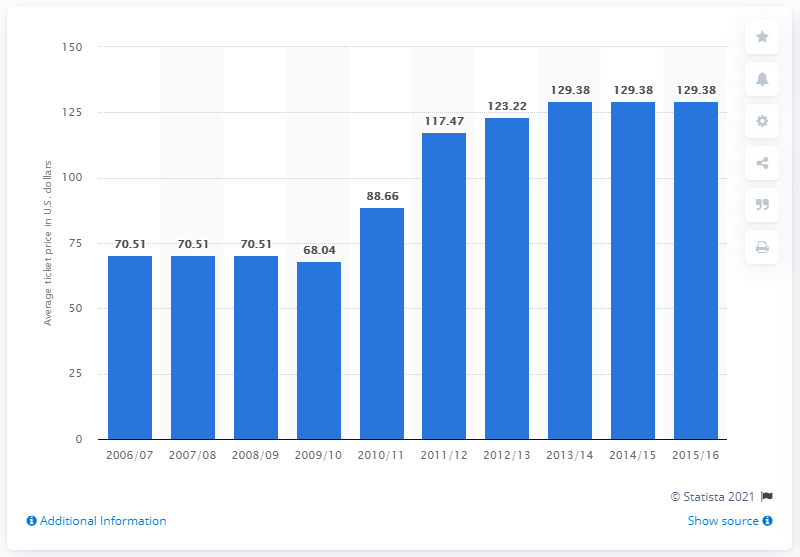Identify some key points in this picture. The average ticket price for New York Knicks games changed in the 2015/2016 season. 